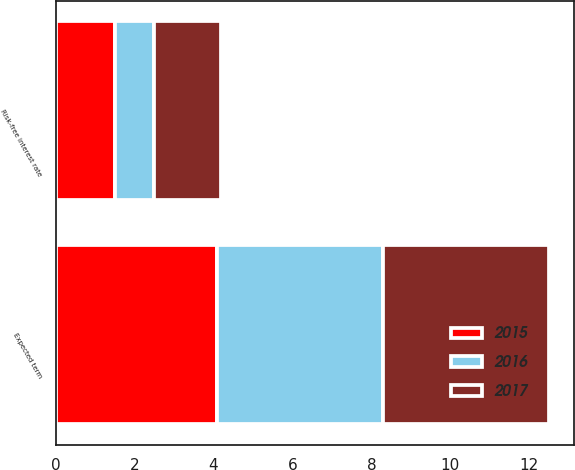<chart> <loc_0><loc_0><loc_500><loc_500><stacked_bar_chart><ecel><fcel>Expected term<fcel>Risk-free interest rate<nl><fcel>2017<fcel>4.2<fcel>1.7<nl><fcel>2016<fcel>4.2<fcel>1<nl><fcel>2015<fcel>4.1<fcel>1.5<nl></chart> 